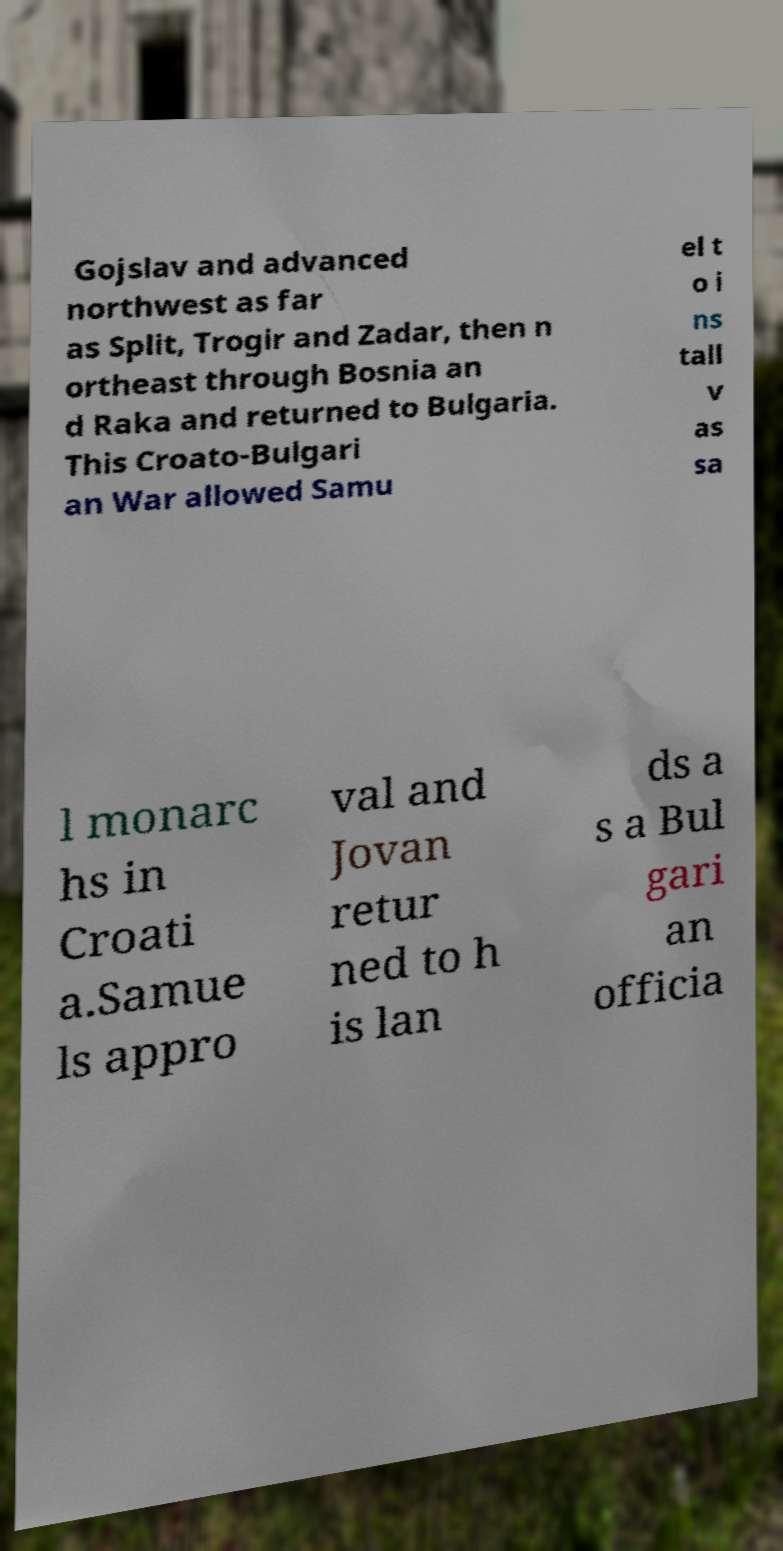What messages or text are displayed in this image? I need them in a readable, typed format. Gojslav and advanced northwest as far as Split, Trogir and Zadar, then n ortheast through Bosnia an d Raka and returned to Bulgaria. This Croato-Bulgari an War allowed Samu el t o i ns tall v as sa l monarc hs in Croati a.Samue ls appro val and Jovan retur ned to h is lan ds a s a Bul gari an officia 